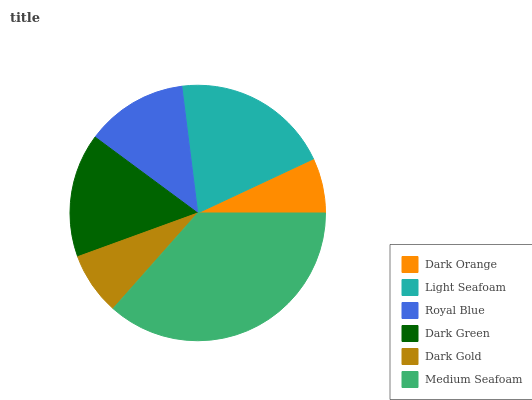Is Dark Orange the minimum?
Answer yes or no. Yes. Is Medium Seafoam the maximum?
Answer yes or no. Yes. Is Light Seafoam the minimum?
Answer yes or no. No. Is Light Seafoam the maximum?
Answer yes or no. No. Is Light Seafoam greater than Dark Orange?
Answer yes or no. Yes. Is Dark Orange less than Light Seafoam?
Answer yes or no. Yes. Is Dark Orange greater than Light Seafoam?
Answer yes or no. No. Is Light Seafoam less than Dark Orange?
Answer yes or no. No. Is Dark Green the high median?
Answer yes or no. Yes. Is Royal Blue the low median?
Answer yes or no. Yes. Is Medium Seafoam the high median?
Answer yes or no. No. Is Dark Green the low median?
Answer yes or no. No. 